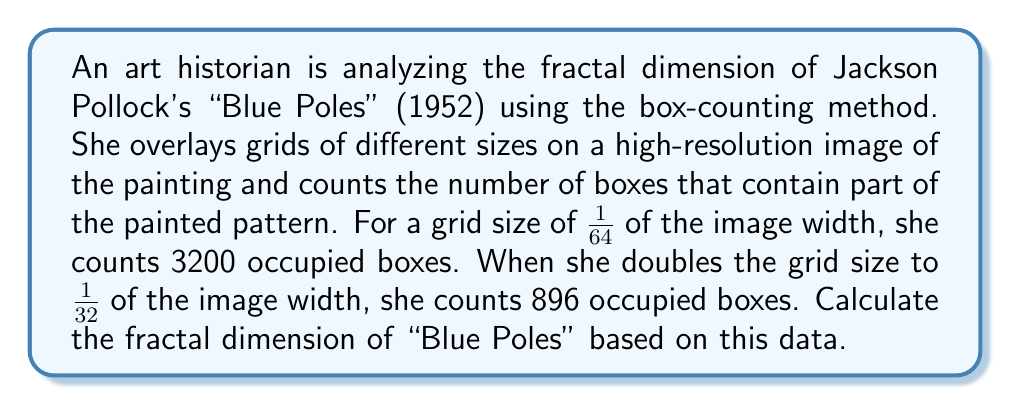Solve this math problem. To determine the fractal dimension using the box-counting method, we need to understand the relationship between the box size and the number of occupied boxes. The fractal dimension $D$ is given by the formula:

$$D = -\frac{\log(N_2/N_1)}{\log(r_2/r_1)}$$

Where:
- $N_1$ and $N_2$ are the number of occupied boxes for two different grid sizes
- $r_1$ and $r_2$ are the corresponding grid sizes

In this case:
- $N_1 = 3200$ (for the smaller grid size)
- $N_2 = 896$ (for the larger grid size)
- $r_1 = 1/64$ (smaller grid size)
- $r_2 = 1/32$ (larger grid size)

Let's substitute these values into the formula:

$$D = -\frac{\log(896/3200)}{\log((1/32)/(1/64))}$$

Simplifying:

$$D = -\frac{\log(0.28)}{\log(2)}$$

Using a calculator or computer:

$$D = -\frac{-1.2729657473063747}{0.6931471805599453}$$

$$D = 1.8366215343327841$$

This value indicates that the fractal dimension of "Blue Poles" is approximately 1.84, which is between a 1-dimensional line (D=1) and a 2-dimensional plane (D=2), suggesting a complex, space-filling pattern characteristic of Pollock's drip paintings.
Answer: The fractal dimension of Jackson Pollock's "Blue Poles" based on the given data is approximately 1.84. 